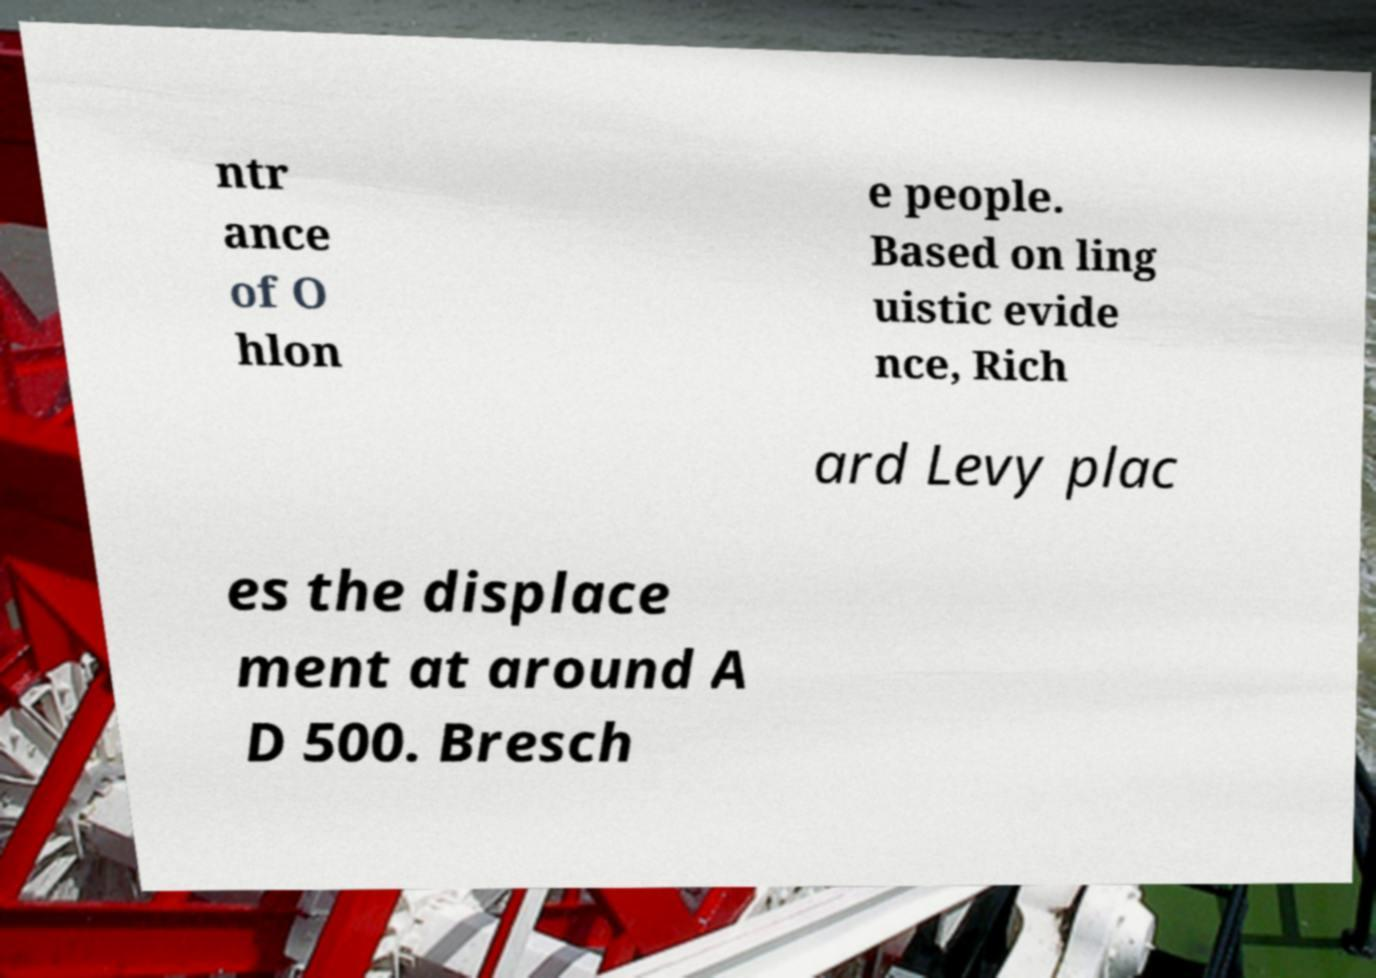I need the written content from this picture converted into text. Can you do that? ntr ance of O hlon e people. Based on ling uistic evide nce, Rich ard Levy plac es the displace ment at around A D 500. Bresch 